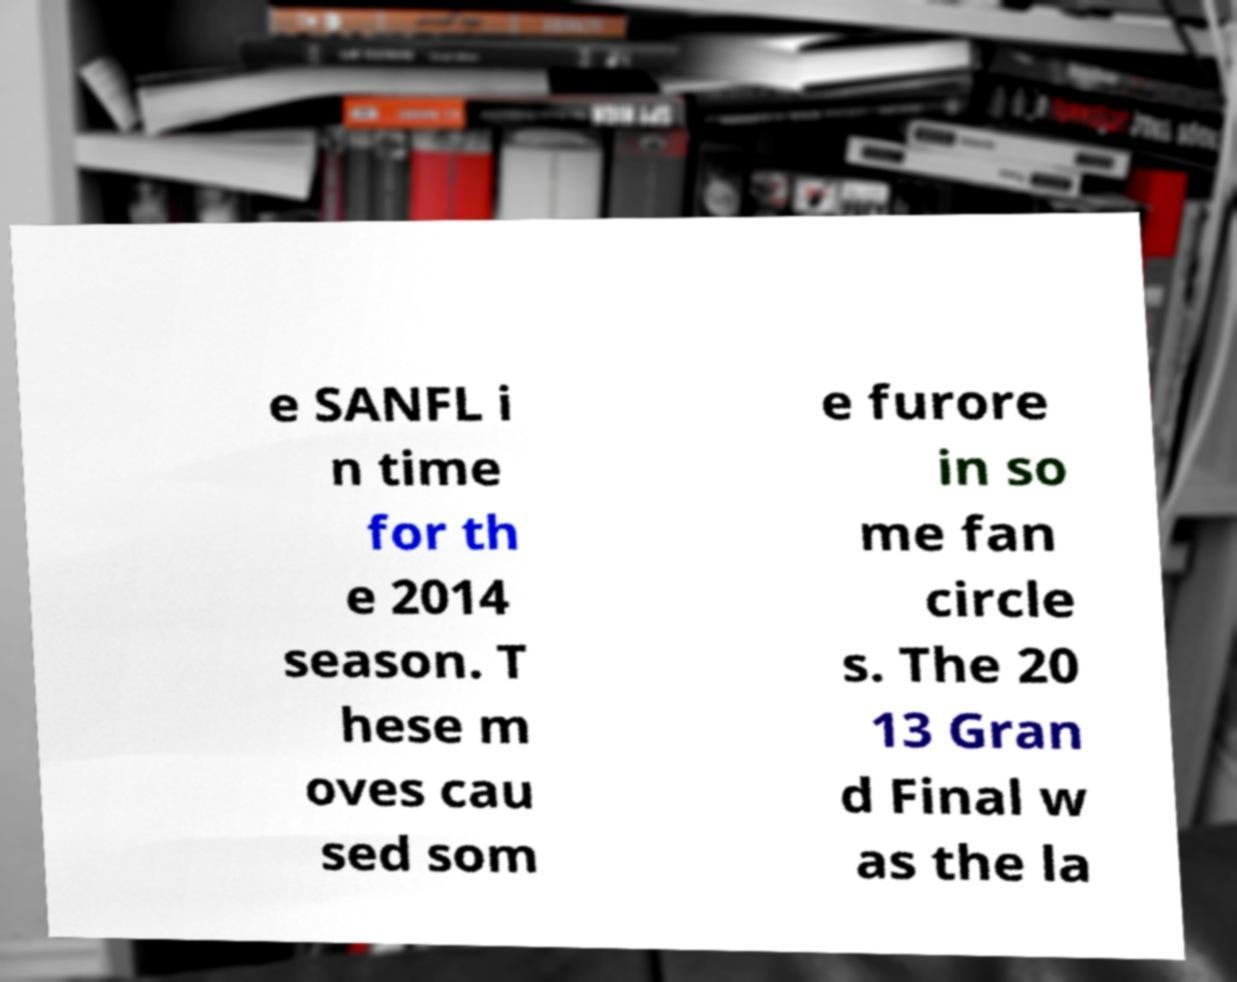What messages or text are displayed in this image? I need them in a readable, typed format. e SANFL i n time for th e 2014 season. T hese m oves cau sed som e furore in so me fan circle s. The 20 13 Gran d Final w as the la 